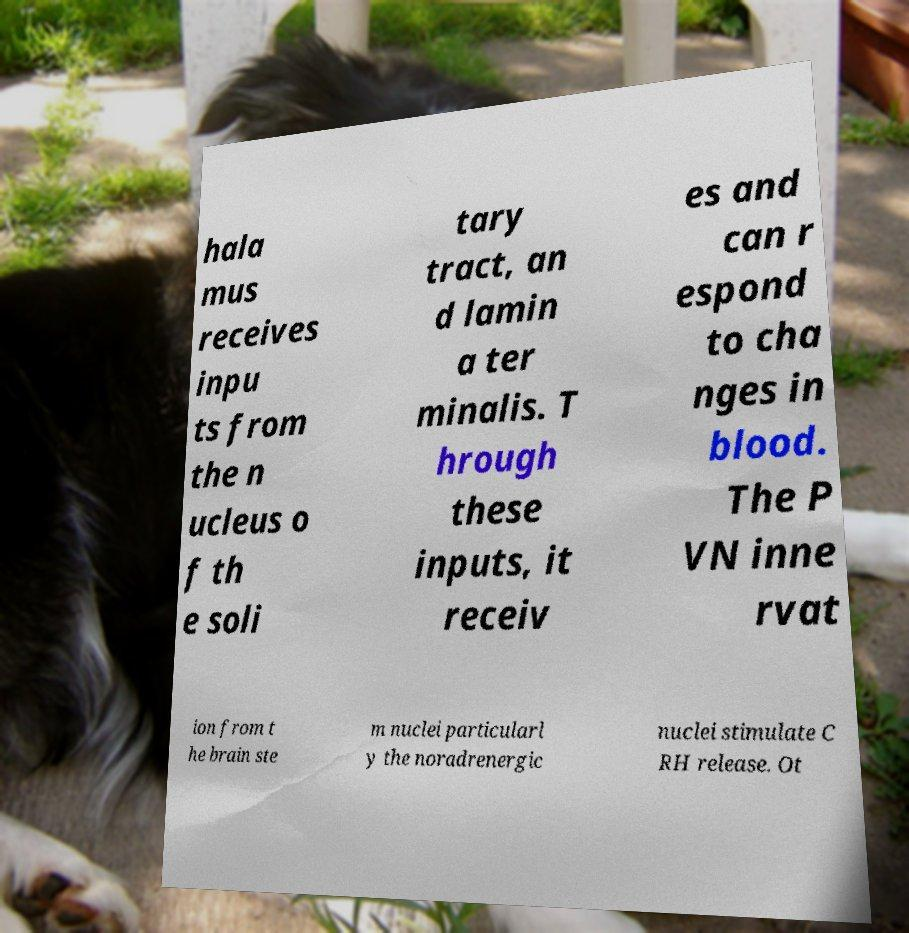Can you accurately transcribe the text from the provided image for me? hala mus receives inpu ts from the n ucleus o f th e soli tary tract, an d lamin a ter minalis. T hrough these inputs, it receiv es and can r espond to cha nges in blood. The P VN inne rvat ion from t he brain ste m nuclei particularl y the noradrenergic nuclei stimulate C RH release. Ot 